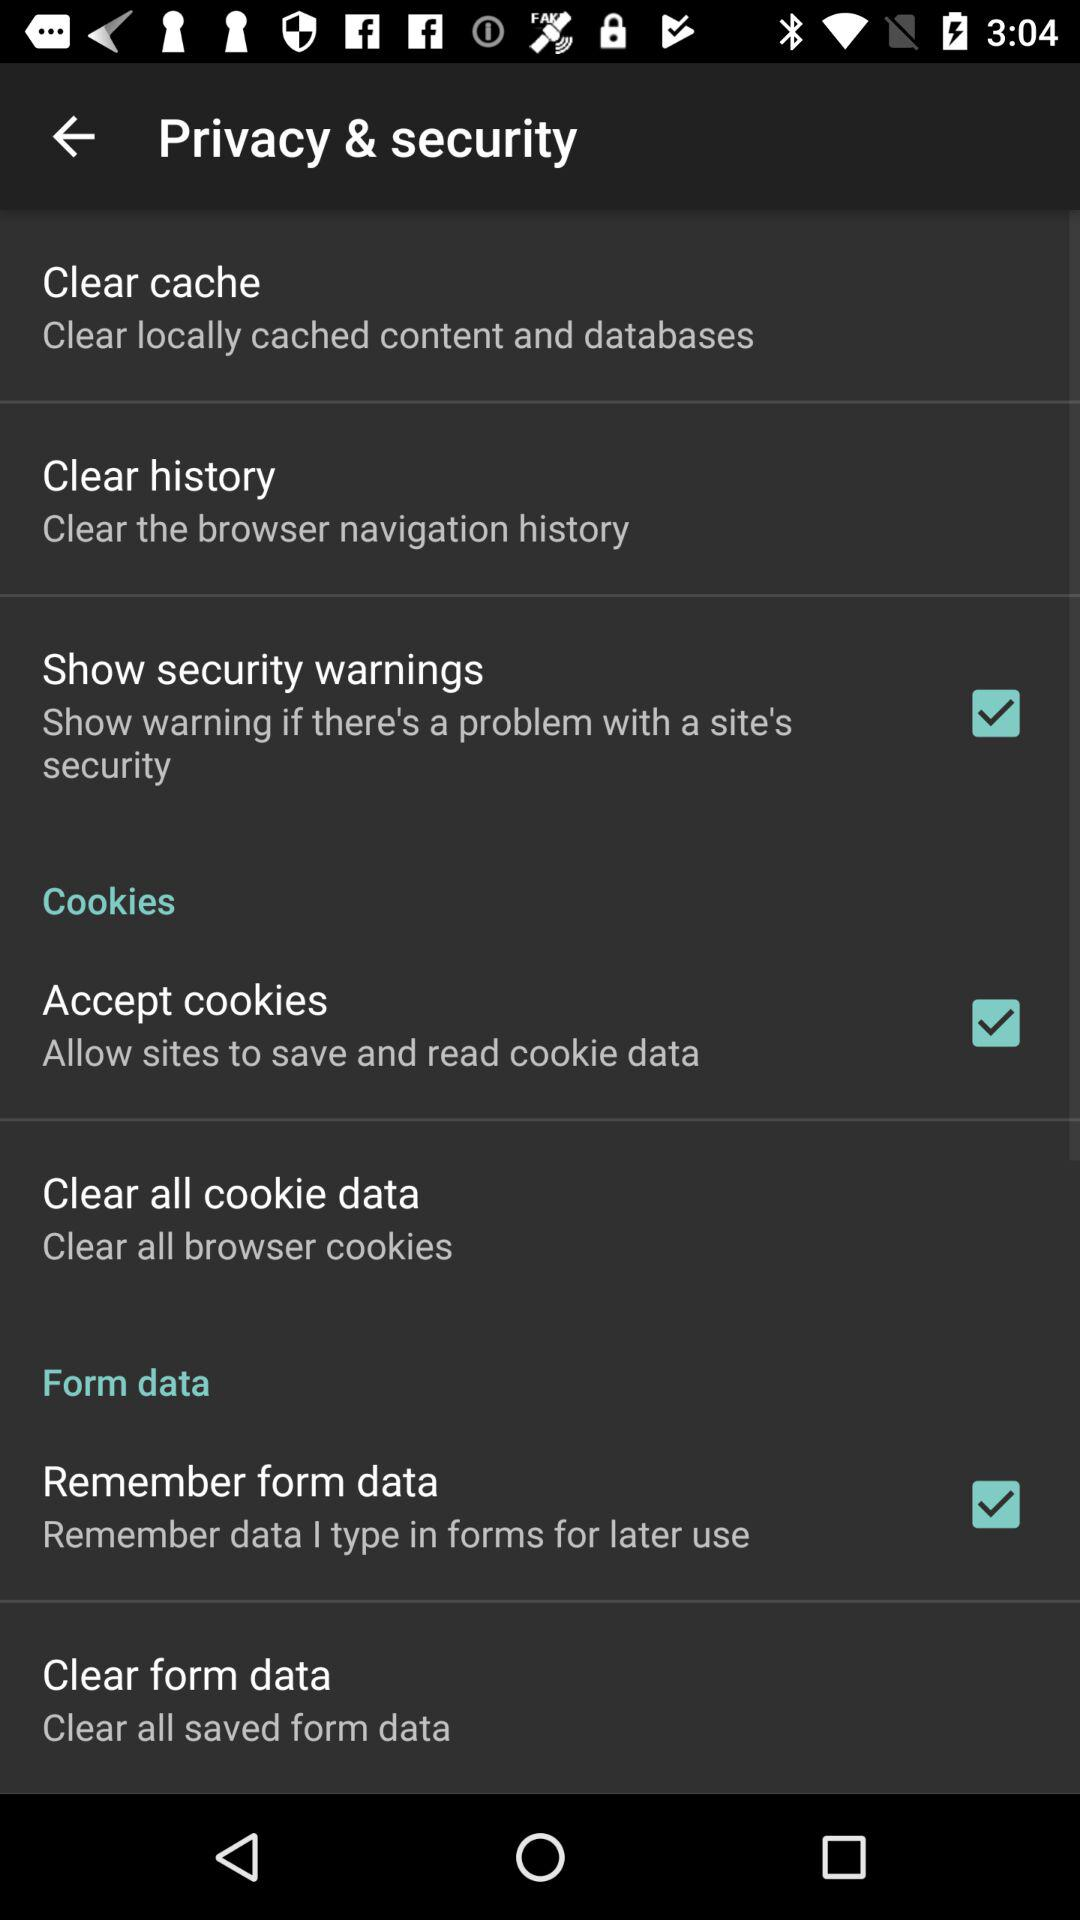How many more items are there in the cookies section than in the security section?
Answer the question using a single word or phrase. 2 